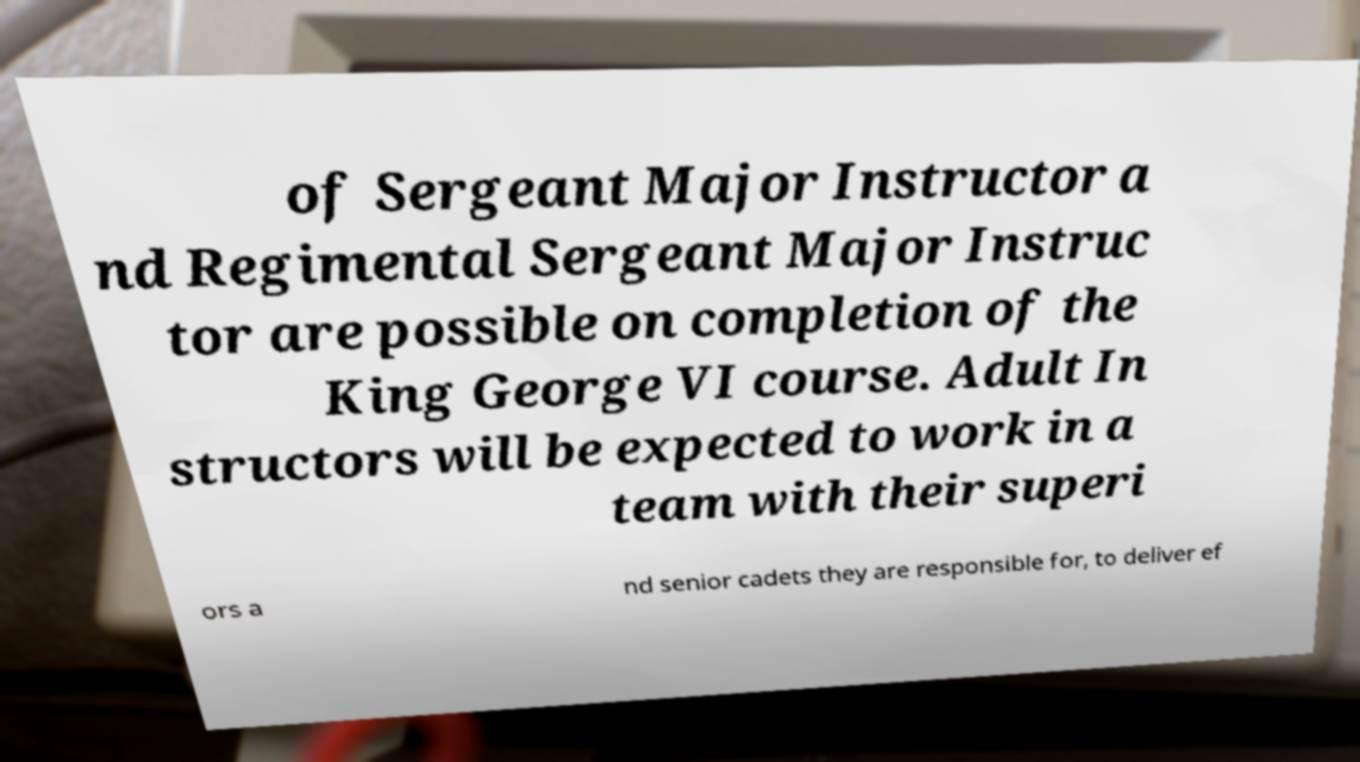Could you assist in decoding the text presented in this image and type it out clearly? of Sergeant Major Instructor a nd Regimental Sergeant Major Instruc tor are possible on completion of the King George VI course. Adult In structors will be expected to work in a team with their superi ors a nd senior cadets they are responsible for, to deliver ef 